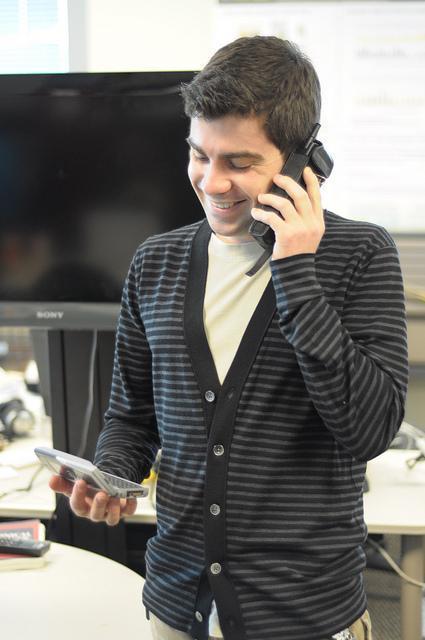How many buttons are on the man's shirt?
Give a very brief answer. 5. How many televisions are in the picture?
Give a very brief answer. 1. How many tvs are visible?
Give a very brief answer. 2. How many cell phones are there?
Give a very brief answer. 2. 